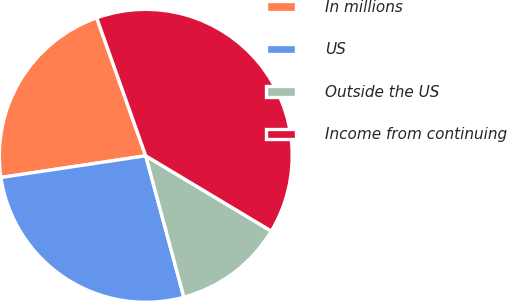Convert chart. <chart><loc_0><loc_0><loc_500><loc_500><pie_chart><fcel>In millions<fcel>US<fcel>Outside the US<fcel>Income from continuing<nl><fcel>21.93%<fcel>26.83%<fcel>12.21%<fcel>39.03%<nl></chart> 